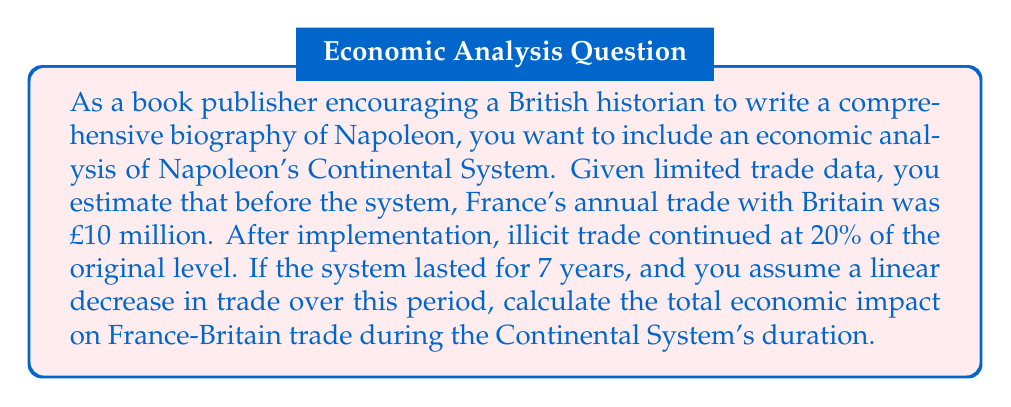Could you help me with this problem? To solve this problem, we need to follow these steps:

1. Calculate the initial and final annual trade values:
   Initial trade: £10 million
   Final trade: 20% of £10 million = £2 million

2. Calculate the annual decrease in trade:
   Total decrease: £10 million - £2 million = £8 million
   Annual decrease: $\frac{£8 \text{ million}}{7 \text{ years}} = £1.14286 \text{ million per year}$

3. Set up the arithmetic sequence for annual trade:
   $a_1 = £10 \text{ million}$ (first year)
   $d = -£1.14286 \text{ million}$ (common difference)
   $n = 7$ (number of terms)

4. Use the arithmetic sequence sum formula:
   $S_n = \frac{n}{2}(a_1 + a_n)$
   Where $a_n = a_1 + (n-1)d = £10 \text{ million} + (7-1)(-£1.14286 \text{ million}) = £3.14286 \text{ million}$

5. Calculate the total trade over 7 years:
   $S_7 = \frac{7}{2}(£10 \text{ million} + £3.14286 \text{ million}) = £45.5 \text{ million}$

6. Compare this to the hypothetical trade without the Continental System:
   Without the system: $7 \times £10 \text{ million} = £70 \text{ million}$

7. Calculate the economic impact:
   Impact = Hypothetical trade - Actual trade
   $£70 \text{ million} - £45.5 \text{ million} = £24.5 \text{ million}$
Answer: £24.5 million 